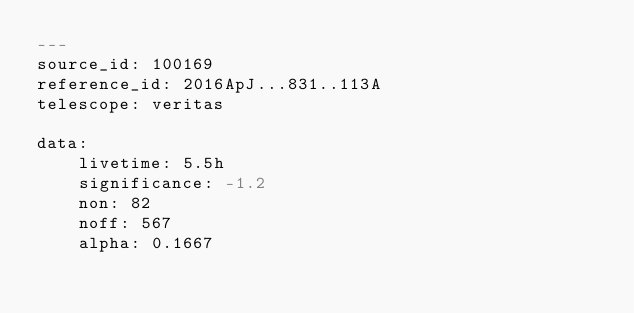<code> <loc_0><loc_0><loc_500><loc_500><_YAML_>---
source_id: 100169
reference_id: 2016ApJ...831..113A
telescope: veritas

data:
    livetime: 5.5h
    significance: -1.2
    non: 82
    noff: 567
    alpha: 0.1667
</code> 